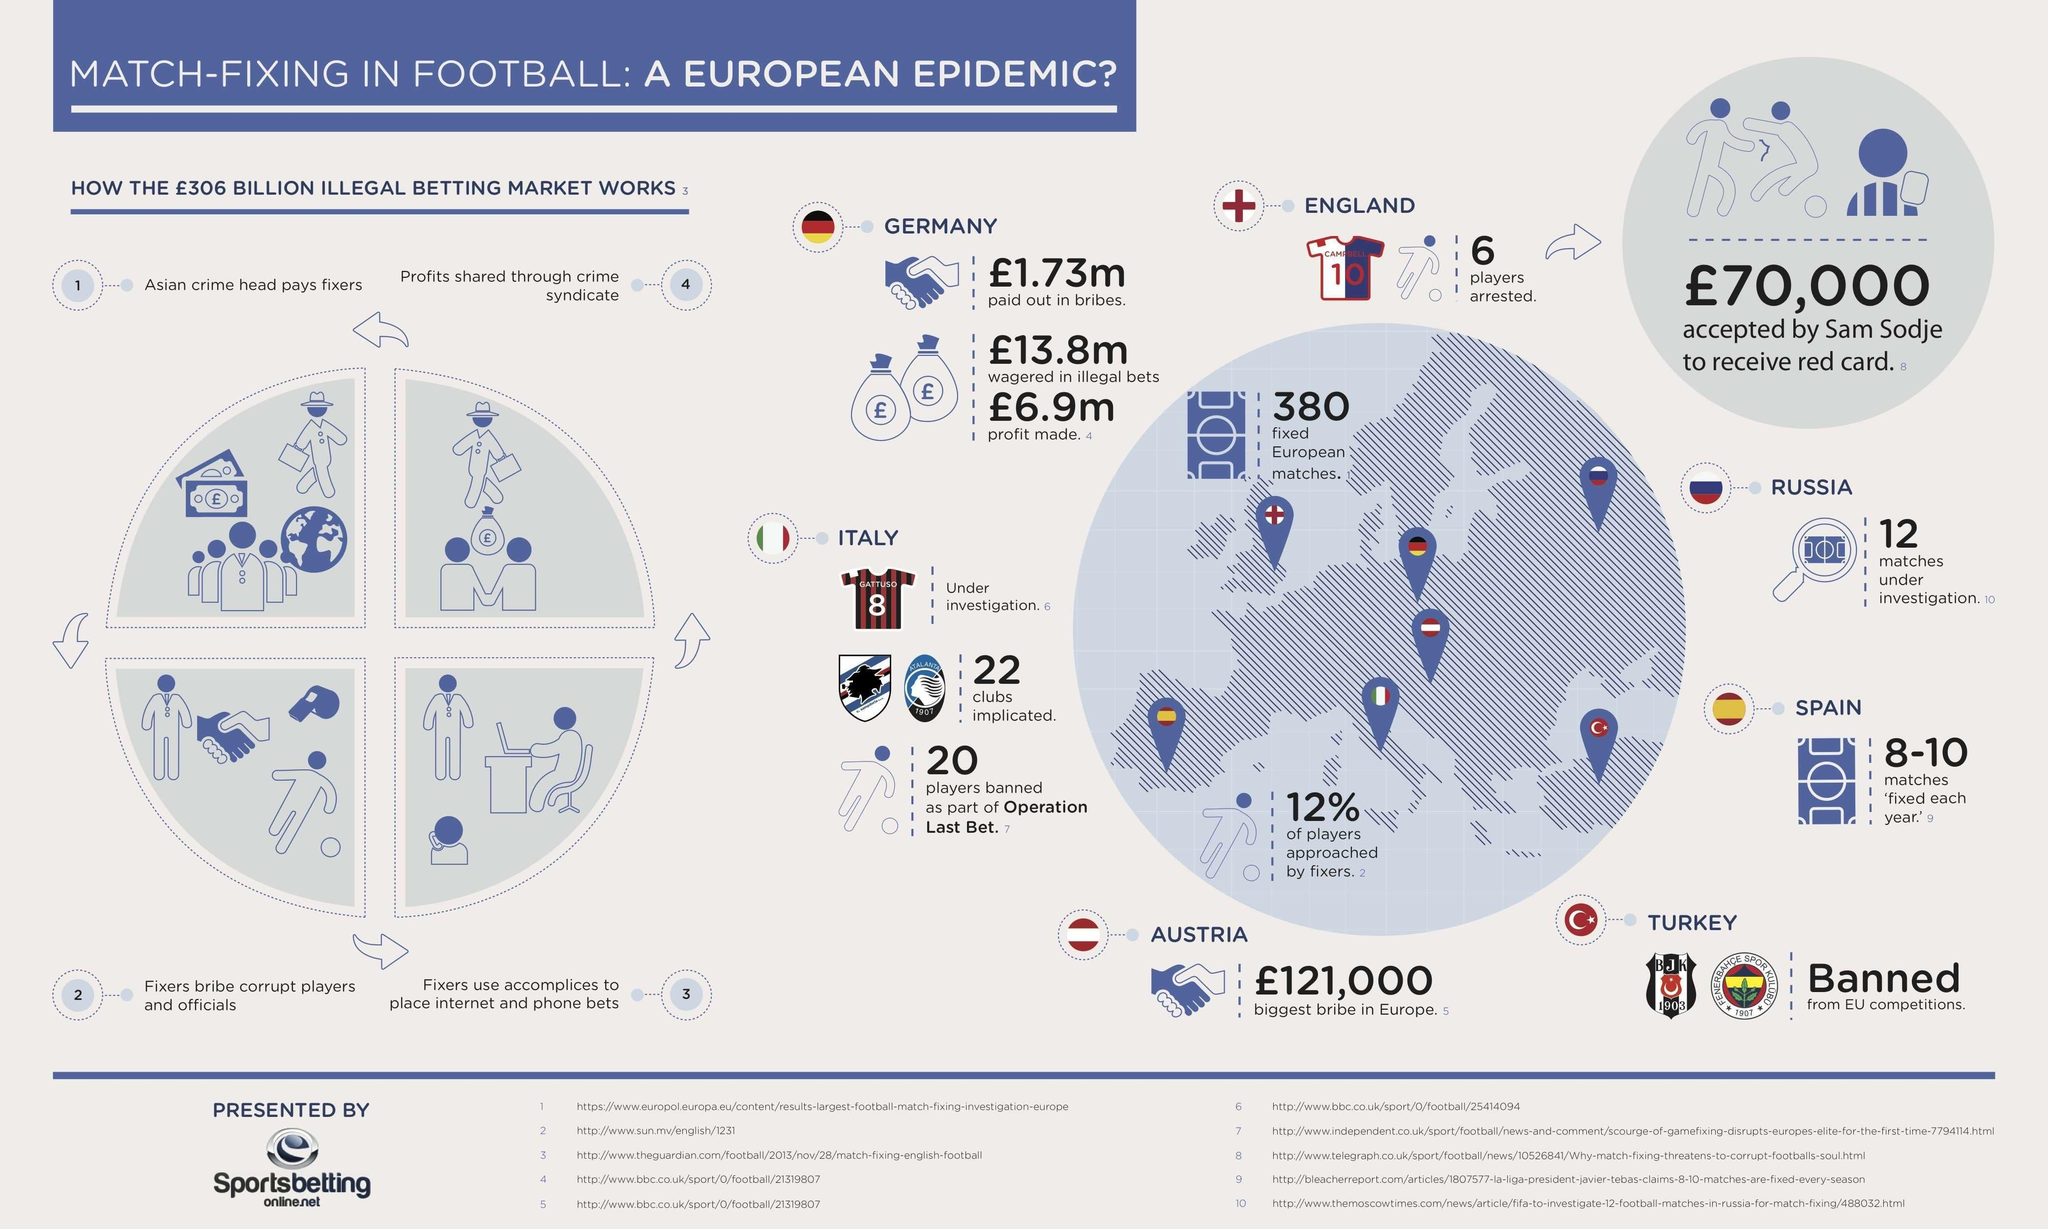Outline some significant characteristics in this image. It is reported that a particular channel is utilized by a criminal syndicate to distribute the proceeds of illegal betting activities. Seven location pins are displayed on the map of Europe. I know the number on the Italian football jersey. It is 8. Turkey has been banned from participating in EU competitions. The number on England's jersey is 10. 